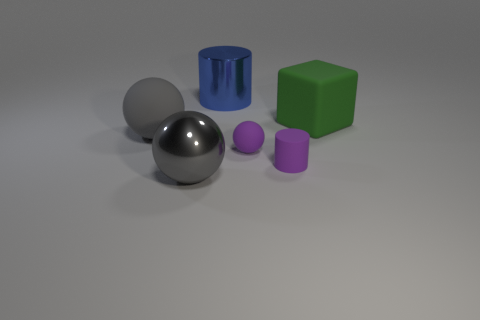Add 4 big balls. How many objects exist? 10 Subtract all blocks. How many objects are left? 5 Subtract all blue metallic cylinders. Subtract all red metal spheres. How many objects are left? 5 Add 1 purple matte spheres. How many purple matte spheres are left? 2 Add 5 large yellow matte things. How many large yellow matte things exist? 5 Subtract 0 gray cylinders. How many objects are left? 6 